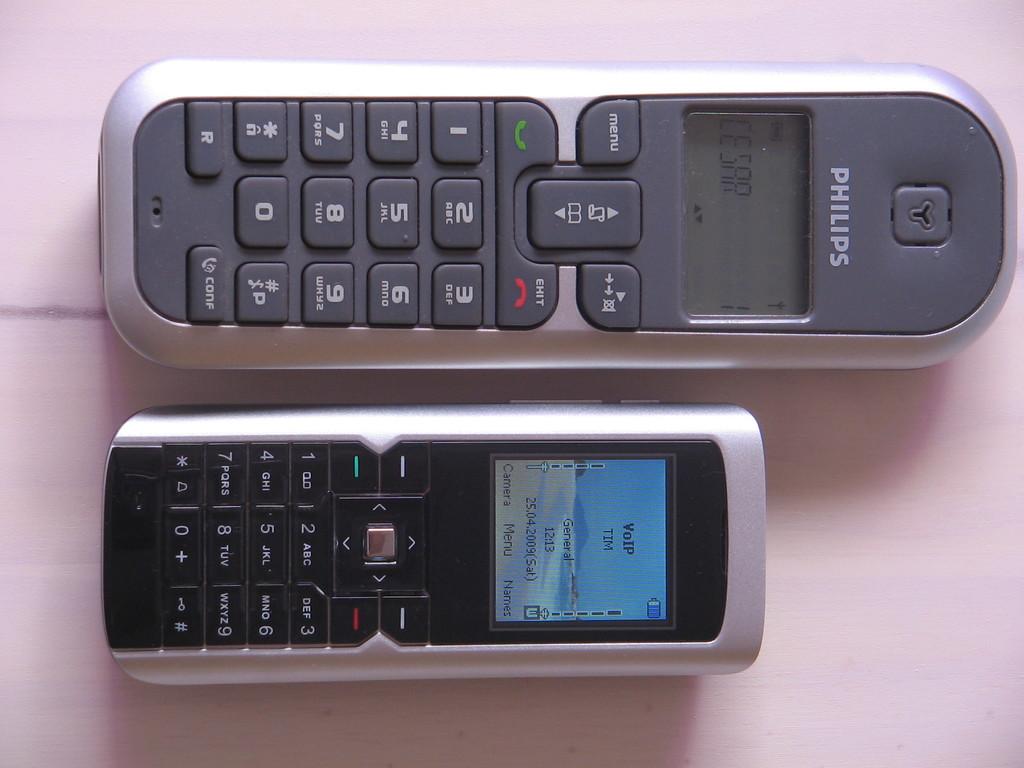What brand is the large gray phone?
Your response must be concise. Philips. What number is shown on the smaller phone?
Give a very brief answer. Unanswerable. 